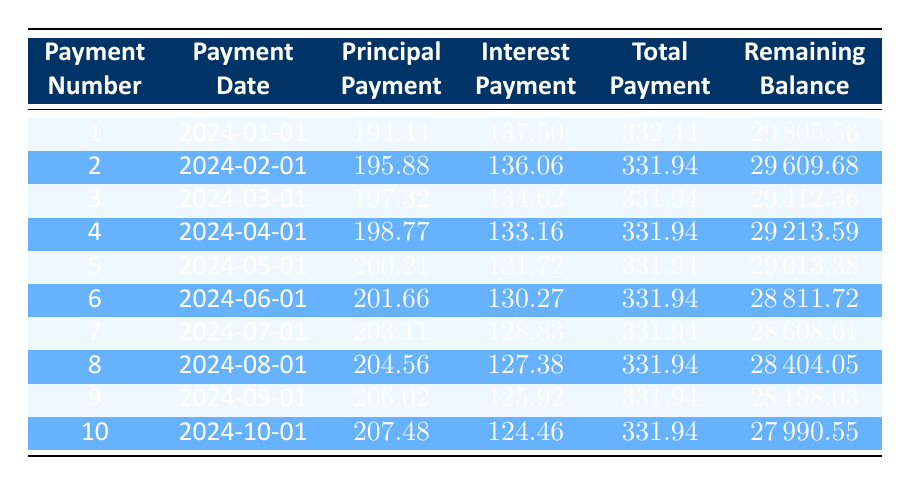What is the total loan amount taken? The total loan amount is provided in the loan details as 30000.
Answer: 30000 What is the monthly payment based on the table? The table specifies that the monthly payment is 322.44.
Answer: 322.44 How much of the first payment goes toward the principal? The first payment details indicate that 194.44 is applied to the principal payment.
Answer: 194.44 What is the interest payment for the second month? According to the second row of the table, the interest payment for the second month is 136.06.
Answer: 136.06 What is the average total payment for the first five months? Summing the total payments for the first five months gives (332.44 + 331.94 + 331.94 + 331.94 + 331.94) = 1657.20, and dividing by 5 gives an average of 331.44.
Answer: 331.44 Is the principal payment for the seventh month higher than that of the first month? The principal payment for the seventh month is 203.11, which is indeed higher than the first month's payment of 194.44, confirming the statement is true.
Answer: Yes What is the total amount remaining after the tenth payment? The remaining balance after the tenth payment, as per the table, is 27990.55.
Answer: 27990.55 How much did the interest payment decrease from the first payment to the fourth payment? The first payment's interest is 137.50 and the fourth payment's interest is 133.16. The decrease is calculated as 137.50 - 133.16 = 4.34.
Answer: 4.34 What is the total amount paid in interest after the first three payments? The total interest paid after the first three payments is calculated as (137.50 + 136.06 + 134.62) = 408.18.
Answer: 408.18 Considering the amounts in the table, is it possible that the remaining balance exceeds the original loan amount after the first month? The remaining balance after the first month is 29805.56, which is less than the original amount of 30000. Thus, the statement is false.
Answer: No 